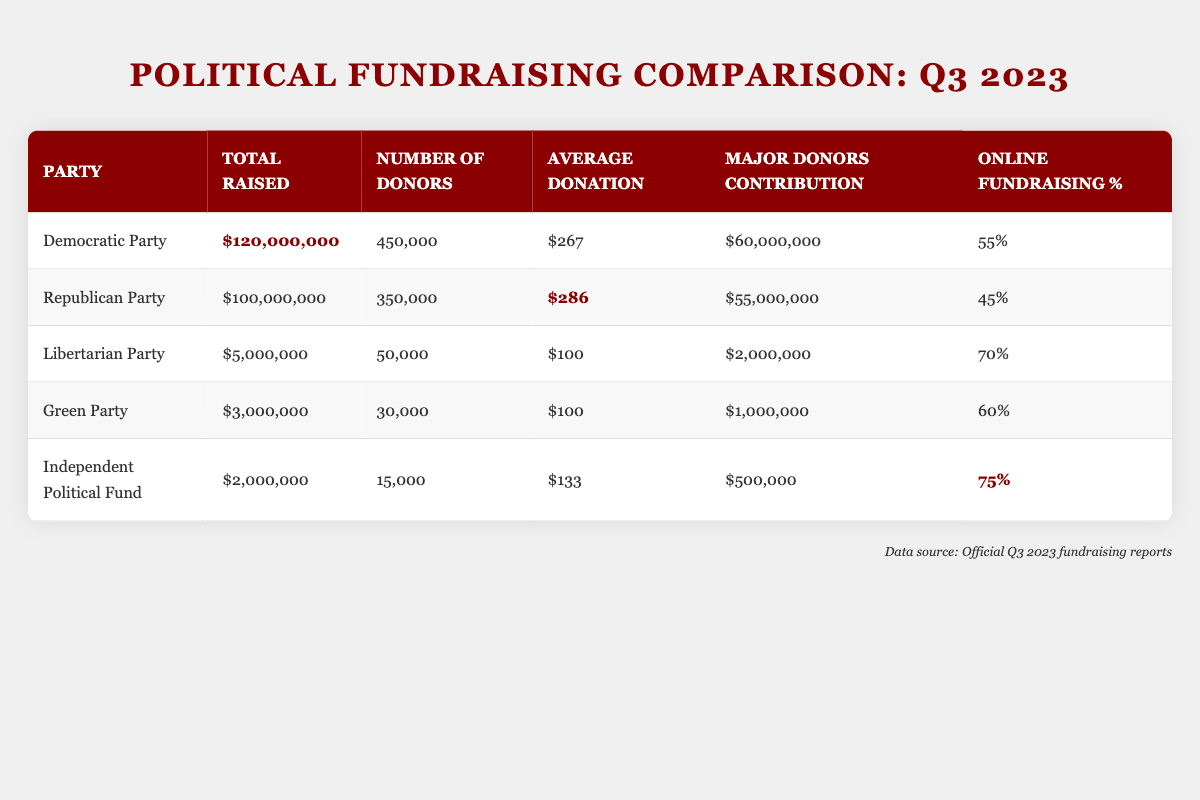What is the total amount raised by the Democratic Party? The table shows that the total amount raised by the Democratic Party in Q3 2023 is listed directly in the "Total Raised" column. The value is 120,000,000.
Answer: 120,000,000 How many donors contributed to the Republican Party's fundraising efforts? The number of donors for the Republican Party is stated in the "Number of Donors" column, which is 350,000.
Answer: 350,000 Which party had the highest average donation per donor? The average donations per donor for each party are listed in the "Average Donation" column. The Democratic Party has an average donation of 267, while the Republican Party has 286, which is higher, so the Republican Party had the highest average donation.
Answer: Republican Party What is the total raised by the Libertarian Party? The total amount raised by the Libertarian Party is found in the "Total Raised" column of the table, which indicates 5,000,000.
Answer: 5,000,000 Did the Green Party raise more money than the Independent Political Fund? By comparing the "Total Raised" values for the Green Party (3,000,000) and the Independent Political Fund (2,000,000) in the table, the Green Party raised more money than the Independent Political Fund.
Answer: Yes What is the overall total amount raised by all parties combined? To find the overall total amount raised, we sum the "Total Raised" values for all parties: 120,000,000 + 100,000,000 + 5,000,000 + 3,000,000 + 2,000,000 = 230,000,000.
Answer: 230,000,000 What percentage of the funds raised by the Democratic Party came from major donors? The major donors' contribution of the Democratic Party is 60,000,000, and the total raised is 120,000,000. Calculating the percentage: (60,000,000 / 120,000,000) * 100 = 50%.
Answer: 50% Which party had the highest percentage of online fundraising? The table lists online fundraising percentages for all parties. The Independent Political Fund has the highest at 75%.
Answer: Independent Political Fund How much did major donors contribute to the Republican Party? The contribution from major donors for the Republican Party is found in the "Major Donors Contribution" column, which is 55,000,000.
Answer: 55,000,000 If you combine the total raised by the Libertarian and Green Parties, do they exceed the total raised by the Independent Political Fund? The totals for the Libertarian Party (5,000,000) and Green Party (3,000,000) combined is 8,000,000. The Independent Political Fund raised 2,000,000. Since 8,000,000 is greater than 2,000,000, they do exceed that amount.
Answer: Yes 